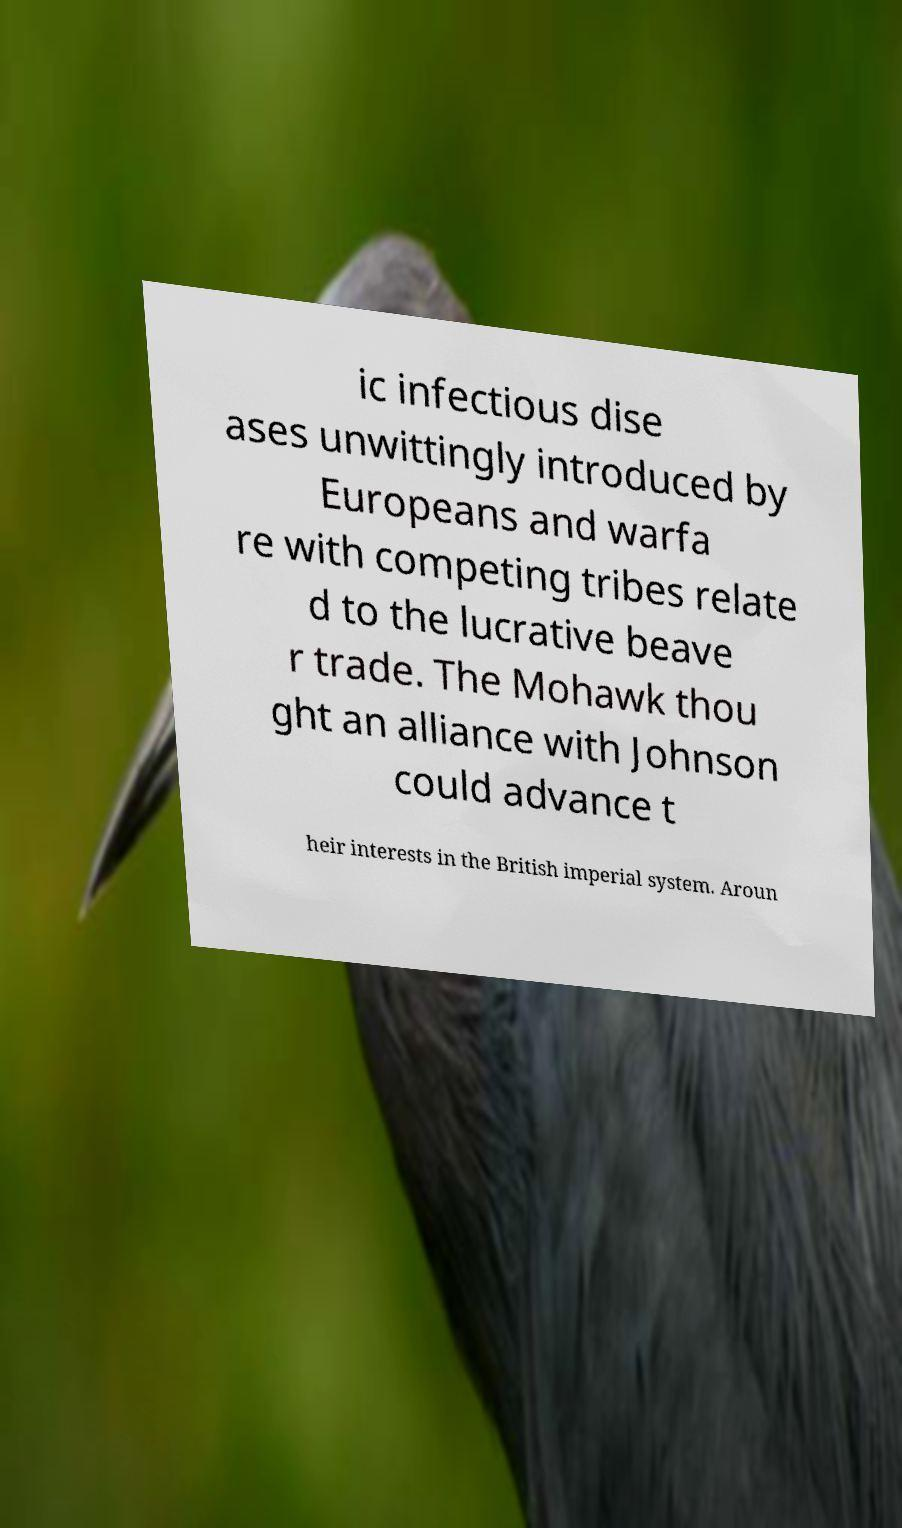Could you assist in decoding the text presented in this image and type it out clearly? ic infectious dise ases unwittingly introduced by Europeans and warfa re with competing tribes relate d to the lucrative beave r trade. The Mohawk thou ght an alliance with Johnson could advance t heir interests in the British imperial system. Aroun 